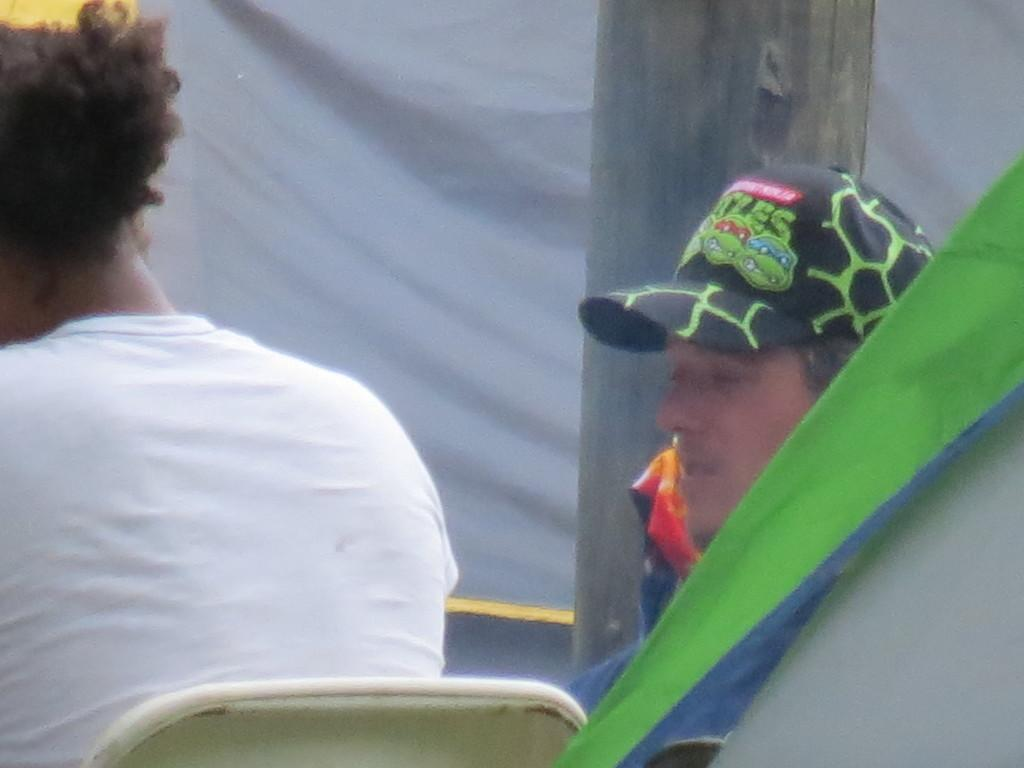How many people are sitting in the image? There are two persons sitting on chairs in the image. Where are the chairs located in relation to the image? The chairs are in the foreground of the image. What can be seen in both the foreground and background of the image? There are covers in both the foreground and background of the image. What is the main object in the center of the image? There appears to be a pole in the center of the image. What type of quill is the doctor using to refuel the pole in the image? There is no quill, doctor, or fuel present in the image. 